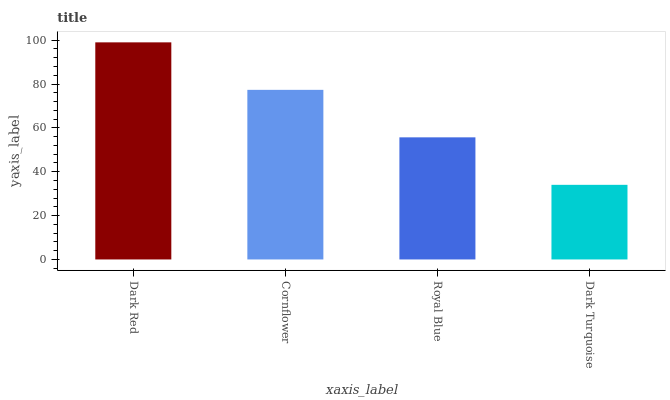Is Dark Turquoise the minimum?
Answer yes or no. Yes. Is Dark Red the maximum?
Answer yes or no. Yes. Is Cornflower the minimum?
Answer yes or no. No. Is Cornflower the maximum?
Answer yes or no. No. Is Dark Red greater than Cornflower?
Answer yes or no. Yes. Is Cornflower less than Dark Red?
Answer yes or no. Yes. Is Cornflower greater than Dark Red?
Answer yes or no. No. Is Dark Red less than Cornflower?
Answer yes or no. No. Is Cornflower the high median?
Answer yes or no. Yes. Is Royal Blue the low median?
Answer yes or no. Yes. Is Dark Turquoise the high median?
Answer yes or no. No. Is Cornflower the low median?
Answer yes or no. No. 